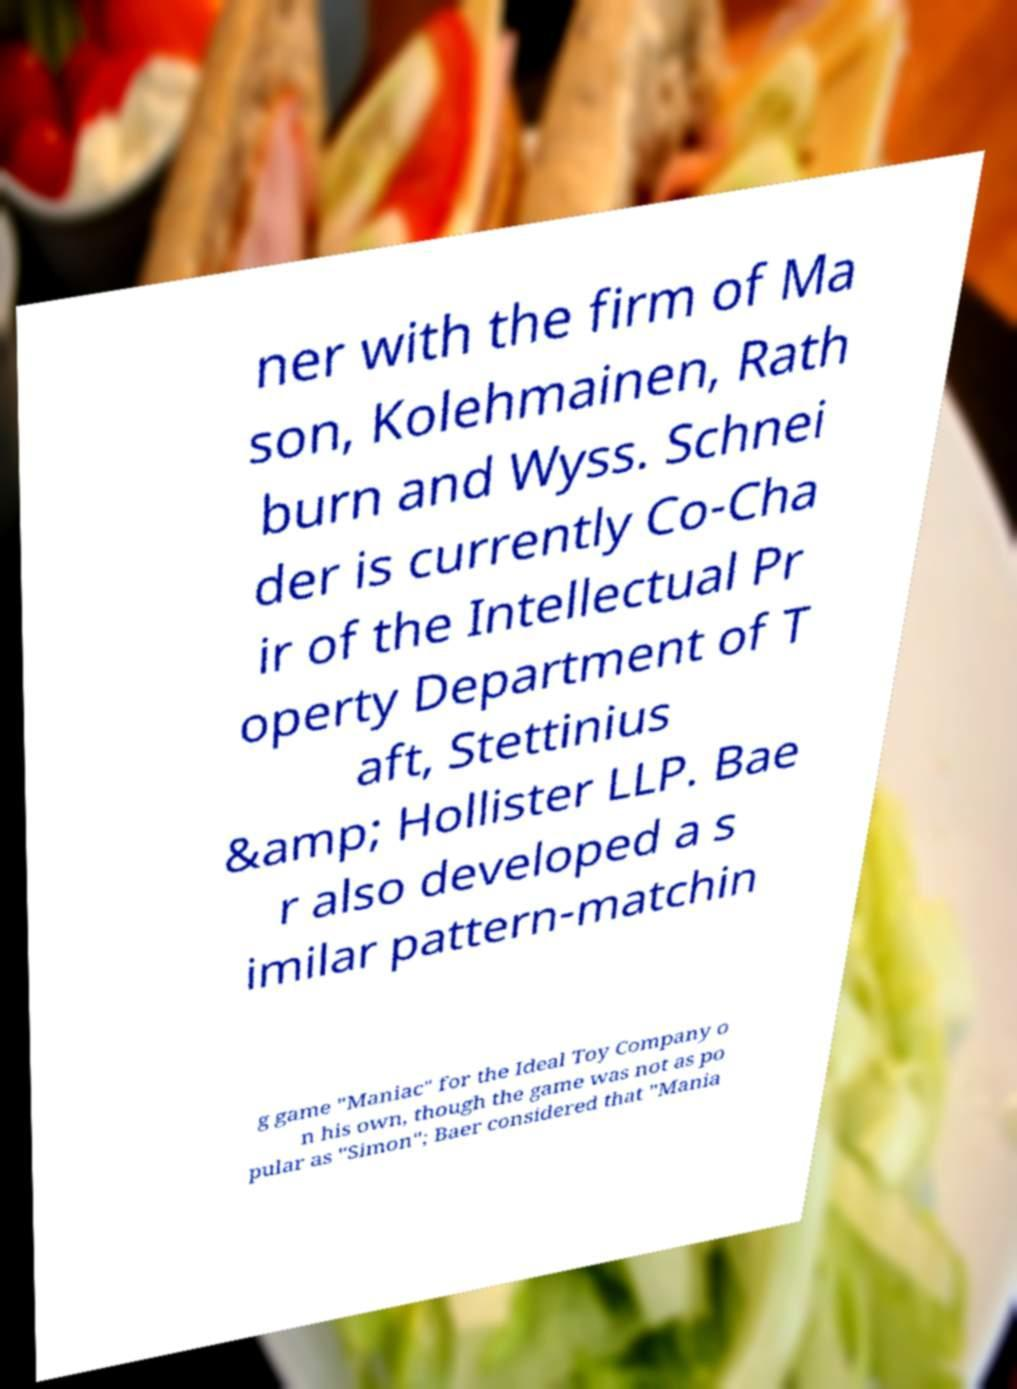Please identify and transcribe the text found in this image. ner with the firm of Ma son, Kolehmainen, Rath burn and Wyss. Schnei der is currently Co-Cha ir of the Intellectual Pr operty Department of T aft, Stettinius &amp; Hollister LLP. Bae r also developed a s imilar pattern-matchin g game "Maniac" for the Ideal Toy Company o n his own, though the game was not as po pular as "Simon"; Baer considered that "Mania 